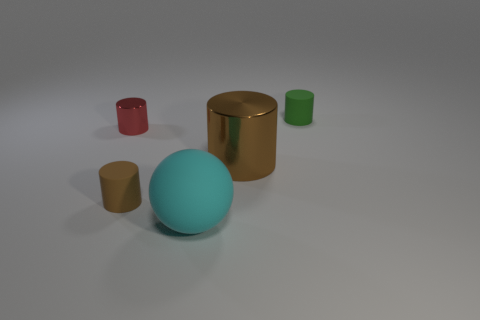There is a rubber cylinder that is right of the matte cylinder that is left of the small cylinder that is behind the tiny red metallic cylinder; what is its size?
Your answer should be very brief. Small. Do the big cyan ball and the brown thing on the left side of the large rubber object have the same material?
Provide a short and direct response. Yes. Is the shape of the tiny green rubber object the same as the tiny red metallic thing?
Provide a short and direct response. Yes. What number of other things are the same material as the small red object?
Ensure brevity in your answer.  1. How many tiny red metal things are the same shape as the brown shiny object?
Give a very brief answer. 1. There is a tiny cylinder that is both behind the large brown object and in front of the green rubber cylinder; what color is it?
Ensure brevity in your answer.  Red. What number of green things are there?
Your response must be concise. 1. Does the green matte cylinder have the same size as the ball?
Ensure brevity in your answer.  No. Are there any small rubber cylinders of the same color as the big metallic thing?
Offer a very short reply. Yes. Do the metal thing that is right of the large cyan thing and the cyan rubber thing have the same shape?
Offer a terse response. No. 